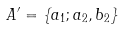<formula> <loc_0><loc_0><loc_500><loc_500>A ^ { \prime } = \{ a _ { 1 } ; a _ { 2 } , b _ { 2 } \}</formula> 